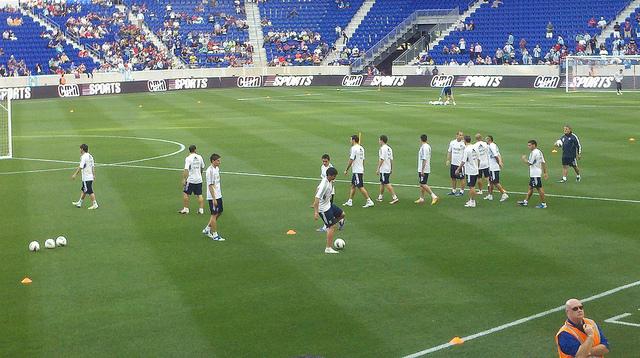What sport is this?
Give a very brief answer. Soccer. Could this be a German soccer team?
Answer briefly. Yes. Is this game sold out?
Answer briefly. No. 